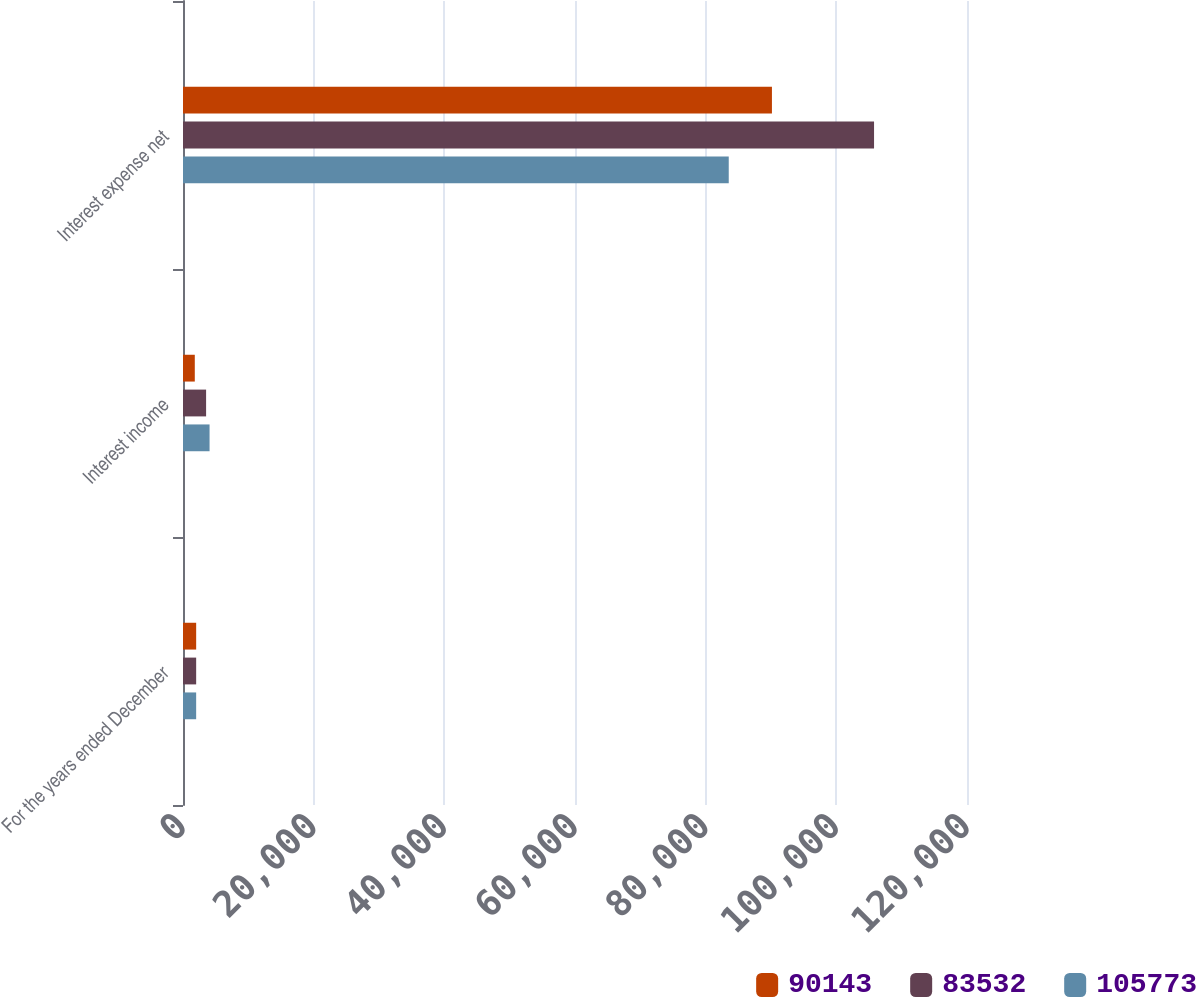Convert chart to OTSL. <chart><loc_0><loc_0><loc_500><loc_500><stacked_bar_chart><ecel><fcel>For the years ended December<fcel>Interest income<fcel>Interest expense net<nl><fcel>90143<fcel>2016<fcel>1805<fcel>90143<nl><fcel>83532<fcel>2015<fcel>3536<fcel>105773<nl><fcel>105773<fcel>2014<fcel>4066<fcel>83532<nl></chart> 